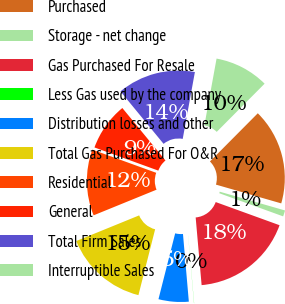Convert chart to OTSL. <chart><loc_0><loc_0><loc_500><loc_500><pie_chart><fcel>Purchased<fcel>Storage - net change<fcel>Gas Purchased For Resale<fcel>Less Gas used by the company<fcel>Distribution losses and other<fcel>Total Gas Purchased For O&R<fcel>Residential<fcel>General<fcel>Total Firm Sales<fcel>Interruptible Sales<nl><fcel>17.01%<fcel>1.08%<fcel>18.07%<fcel>0.02%<fcel>5.33%<fcel>14.89%<fcel>11.7%<fcel>8.51%<fcel>13.82%<fcel>9.58%<nl></chart> 